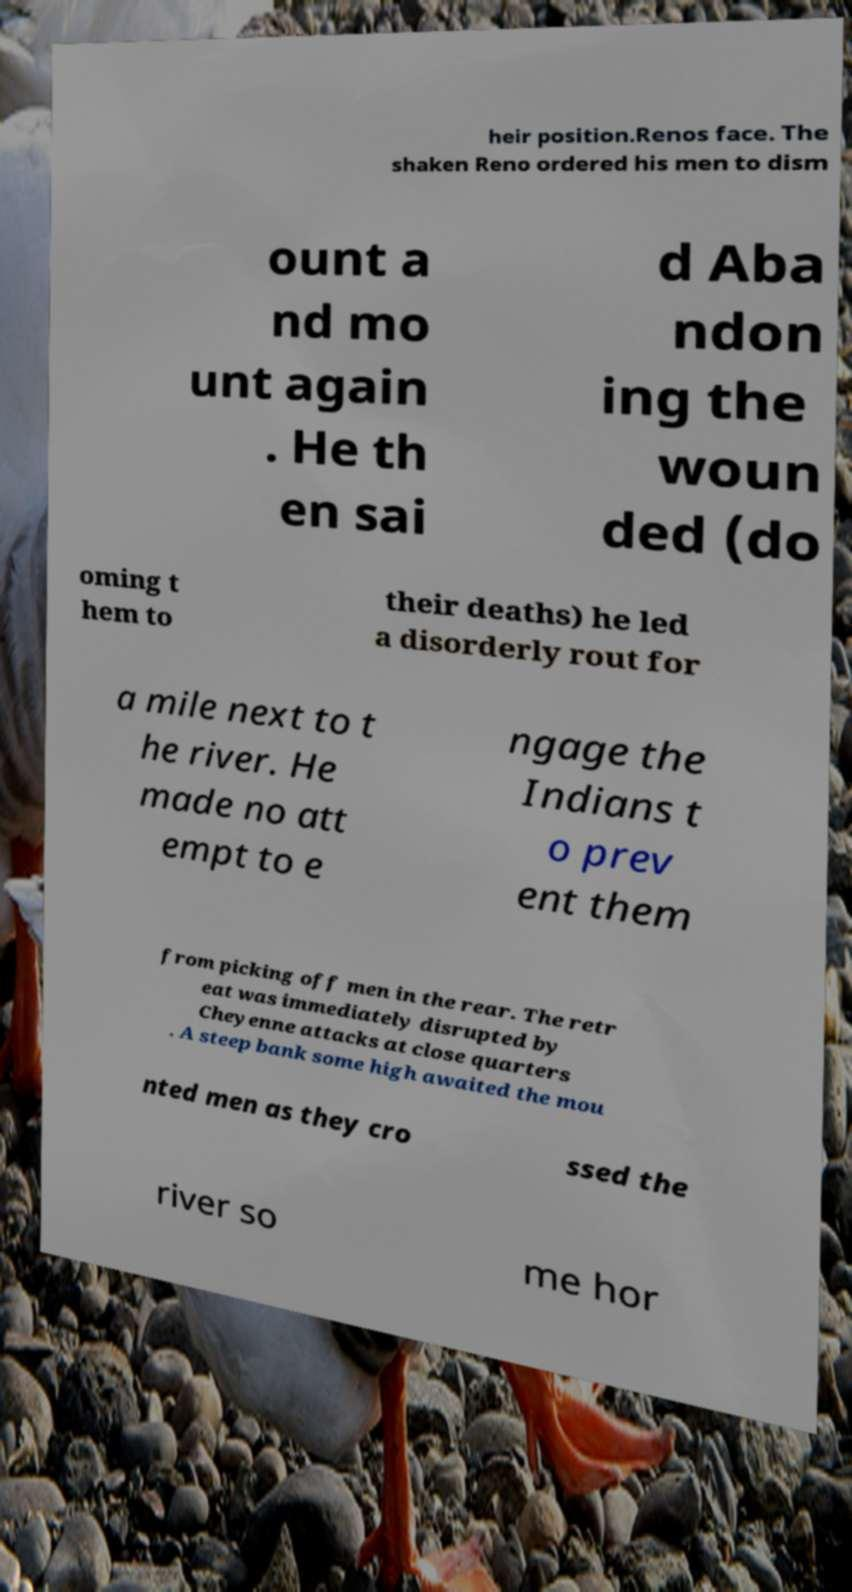I need the written content from this picture converted into text. Can you do that? heir position.Renos face. The shaken Reno ordered his men to dism ount a nd mo unt again . He th en sai d Aba ndon ing the woun ded (do oming t hem to their deaths) he led a disorderly rout for a mile next to t he river. He made no att empt to e ngage the Indians t o prev ent them from picking off men in the rear. The retr eat was immediately disrupted by Cheyenne attacks at close quarters . A steep bank some high awaited the mou nted men as they cro ssed the river so me hor 